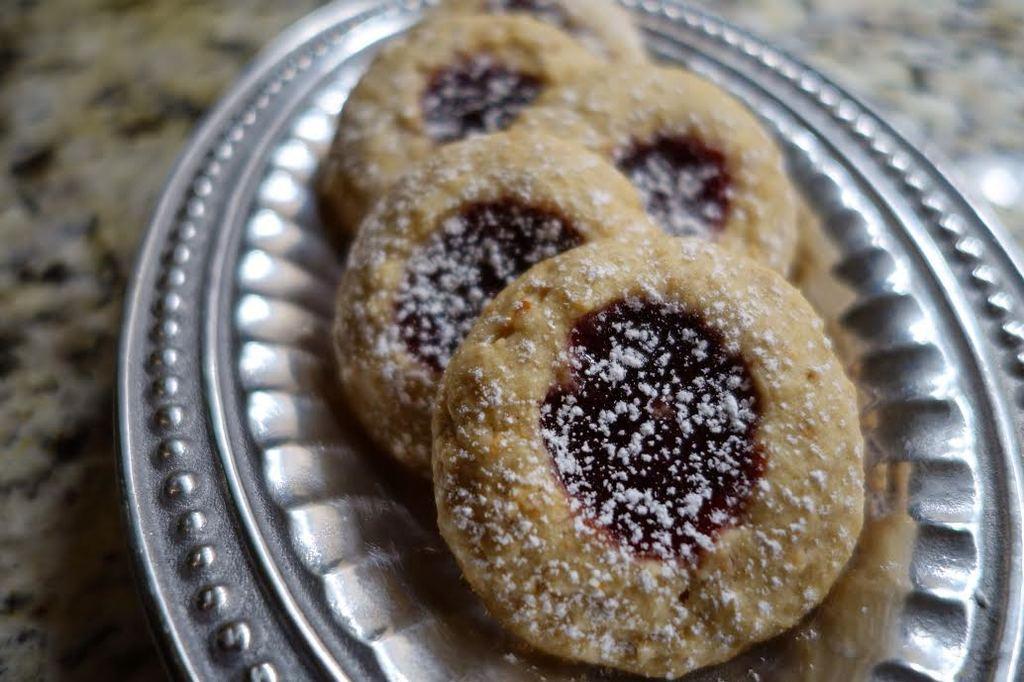How would you summarize this image in a sentence or two? In this image I can see the food on the plate. The food is in brown, white and black color. And the plate is in silver color. It is on the surface. 